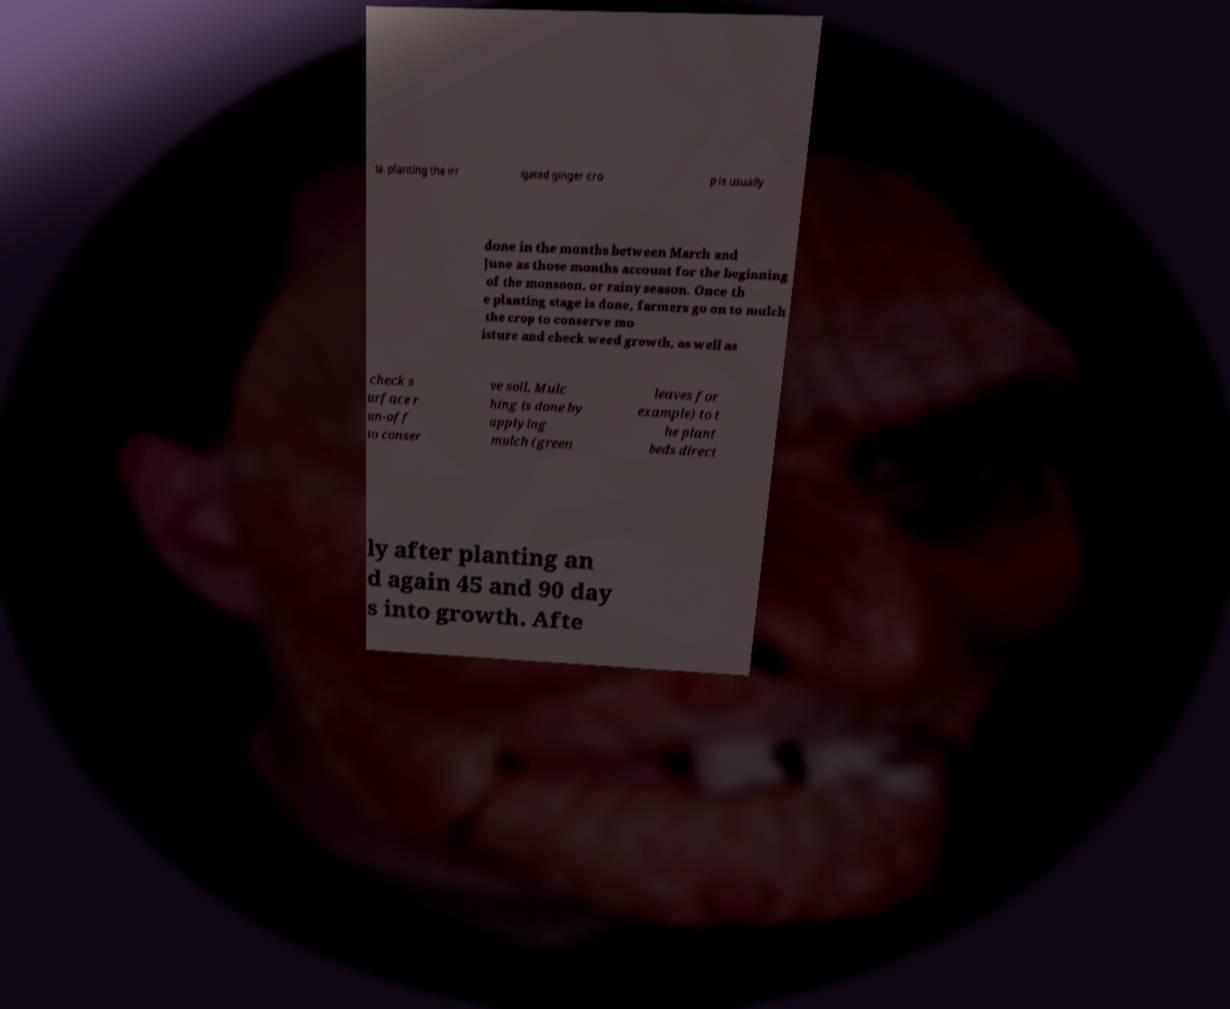Could you extract and type out the text from this image? ia, planting the irr igated ginger cro p is usually done in the months between March and June as those months account for the beginning of the monsoon, or rainy season. Once th e planting stage is done, farmers go on to mulch the crop to conserve mo isture and check weed growth, as well as check s urface r un-off to conser ve soil. Mulc hing is done by applying mulch (green leaves for example) to t he plant beds direct ly after planting an d again 45 and 90 day s into growth. Afte 